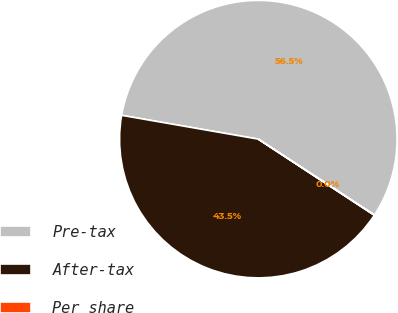Convert chart. <chart><loc_0><loc_0><loc_500><loc_500><pie_chart><fcel>Pre-tax<fcel>After-tax<fcel>Per share<nl><fcel>56.46%<fcel>43.51%<fcel>0.03%<nl></chart> 